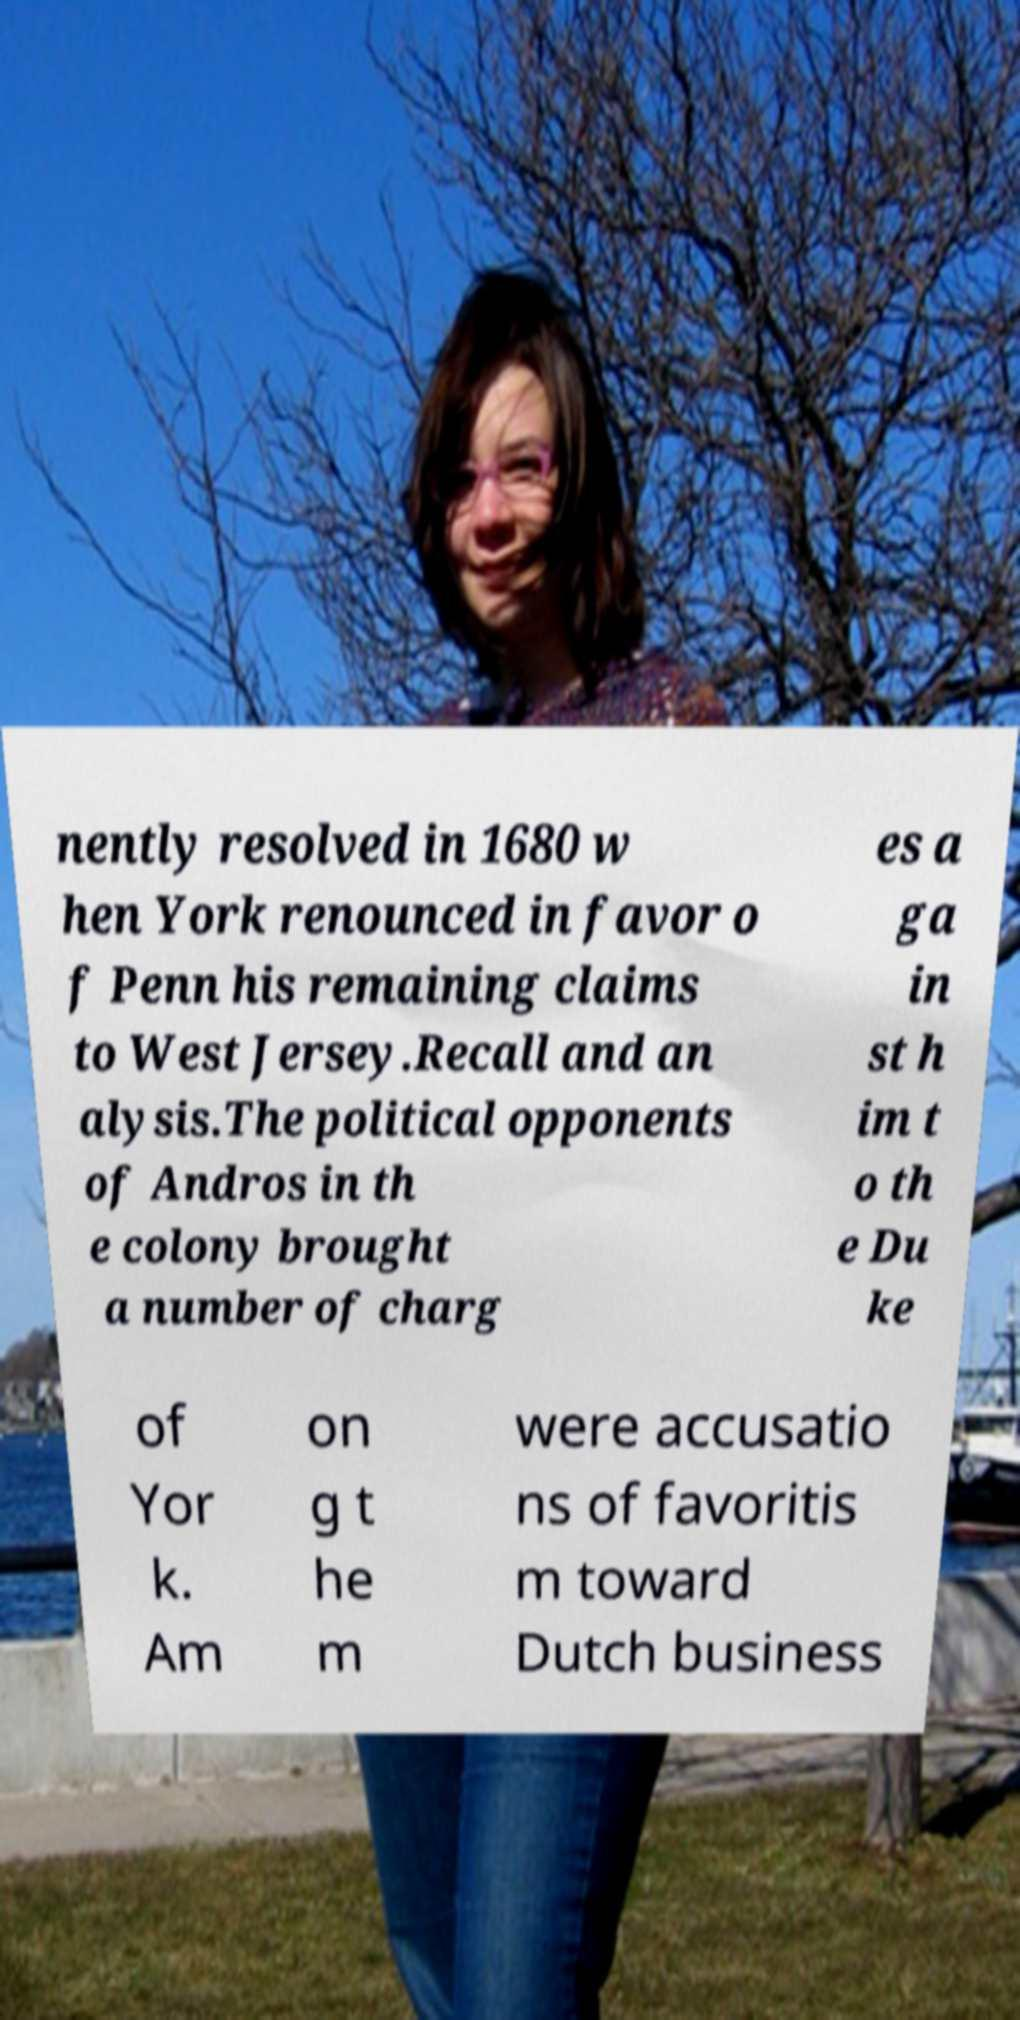Can you read and provide the text displayed in the image?This photo seems to have some interesting text. Can you extract and type it out for me? nently resolved in 1680 w hen York renounced in favor o f Penn his remaining claims to West Jersey.Recall and an alysis.The political opponents of Andros in th e colony brought a number of charg es a ga in st h im t o th e Du ke of Yor k. Am on g t he m were accusatio ns of favoritis m toward Dutch business 